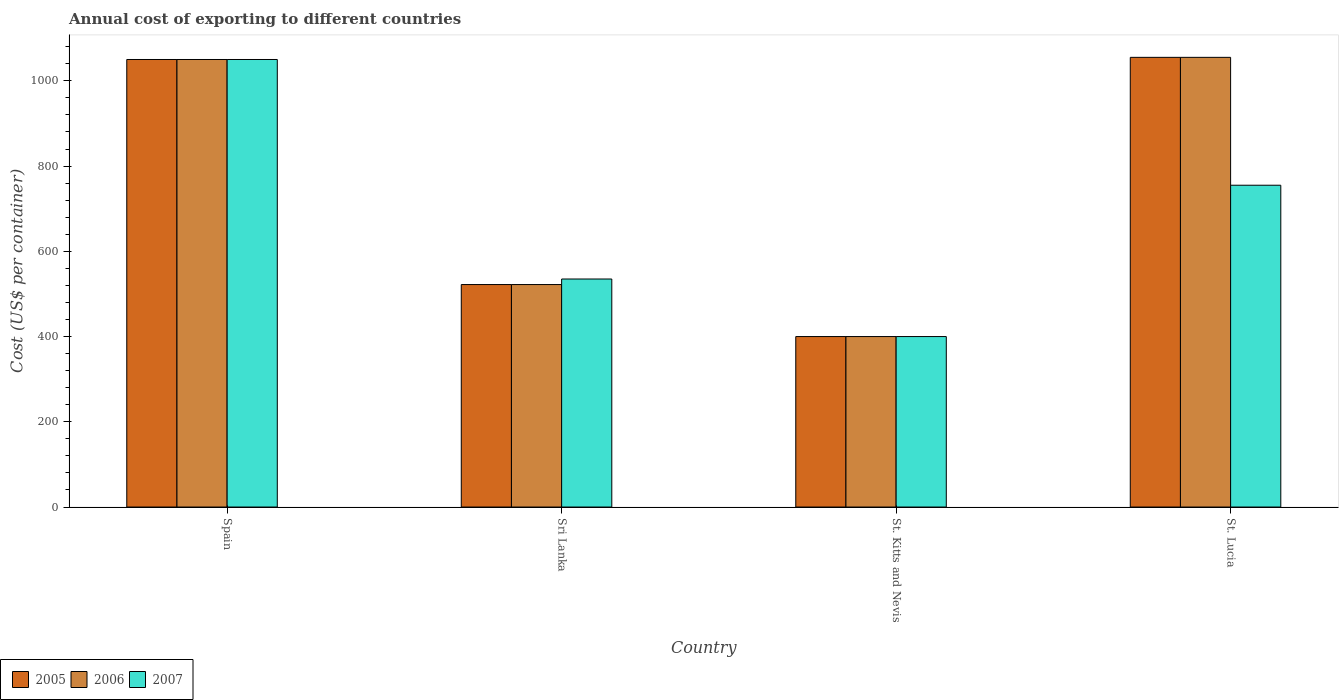How many groups of bars are there?
Your response must be concise. 4. How many bars are there on the 1st tick from the right?
Offer a very short reply. 3. What is the label of the 2nd group of bars from the left?
Your response must be concise. Sri Lanka. In how many cases, is the number of bars for a given country not equal to the number of legend labels?
Keep it short and to the point. 0. Across all countries, what is the maximum total annual cost of exporting in 2007?
Provide a short and direct response. 1050. Across all countries, what is the minimum total annual cost of exporting in 2005?
Provide a succinct answer. 400. In which country was the total annual cost of exporting in 2006 maximum?
Keep it short and to the point. St. Lucia. In which country was the total annual cost of exporting in 2005 minimum?
Your answer should be compact. St. Kitts and Nevis. What is the total total annual cost of exporting in 2007 in the graph?
Your response must be concise. 2740. What is the difference between the total annual cost of exporting in 2006 in Sri Lanka and that in St. Lucia?
Provide a succinct answer. -533. What is the difference between the total annual cost of exporting in 2005 in St. Lucia and the total annual cost of exporting in 2007 in Sri Lanka?
Your answer should be compact. 520. What is the average total annual cost of exporting in 2005 per country?
Make the answer very short. 756.75. In how many countries, is the total annual cost of exporting in 2006 greater than 600 US$?
Your answer should be very brief. 2. What is the ratio of the total annual cost of exporting in 2007 in Sri Lanka to that in St. Kitts and Nevis?
Offer a terse response. 1.34. Is the difference between the total annual cost of exporting in 2006 in Spain and St. Lucia greater than the difference between the total annual cost of exporting in 2005 in Spain and St. Lucia?
Provide a succinct answer. No. What is the difference between the highest and the second highest total annual cost of exporting in 2005?
Your answer should be very brief. 528. What is the difference between the highest and the lowest total annual cost of exporting in 2007?
Your response must be concise. 650. In how many countries, is the total annual cost of exporting in 2007 greater than the average total annual cost of exporting in 2007 taken over all countries?
Provide a short and direct response. 2. Is the sum of the total annual cost of exporting in 2007 in St. Kitts and Nevis and St. Lucia greater than the maximum total annual cost of exporting in 2005 across all countries?
Keep it short and to the point. Yes. What does the 1st bar from the left in St. Lucia represents?
Provide a short and direct response. 2005. Are all the bars in the graph horizontal?
Provide a succinct answer. No. Where does the legend appear in the graph?
Offer a terse response. Bottom left. How are the legend labels stacked?
Provide a succinct answer. Horizontal. What is the title of the graph?
Give a very brief answer. Annual cost of exporting to different countries. What is the label or title of the X-axis?
Ensure brevity in your answer.  Country. What is the label or title of the Y-axis?
Offer a terse response. Cost (US$ per container). What is the Cost (US$ per container) of 2005 in Spain?
Your answer should be very brief. 1050. What is the Cost (US$ per container) in 2006 in Spain?
Your answer should be very brief. 1050. What is the Cost (US$ per container) in 2007 in Spain?
Your answer should be very brief. 1050. What is the Cost (US$ per container) in 2005 in Sri Lanka?
Keep it short and to the point. 522. What is the Cost (US$ per container) in 2006 in Sri Lanka?
Offer a very short reply. 522. What is the Cost (US$ per container) in 2007 in Sri Lanka?
Ensure brevity in your answer.  535. What is the Cost (US$ per container) in 2006 in St. Kitts and Nevis?
Offer a terse response. 400. What is the Cost (US$ per container) of 2007 in St. Kitts and Nevis?
Make the answer very short. 400. What is the Cost (US$ per container) in 2005 in St. Lucia?
Your answer should be very brief. 1055. What is the Cost (US$ per container) in 2006 in St. Lucia?
Your response must be concise. 1055. What is the Cost (US$ per container) of 2007 in St. Lucia?
Your answer should be very brief. 755. Across all countries, what is the maximum Cost (US$ per container) of 2005?
Provide a short and direct response. 1055. Across all countries, what is the maximum Cost (US$ per container) of 2006?
Ensure brevity in your answer.  1055. Across all countries, what is the maximum Cost (US$ per container) of 2007?
Keep it short and to the point. 1050. Across all countries, what is the minimum Cost (US$ per container) in 2005?
Your response must be concise. 400. Across all countries, what is the minimum Cost (US$ per container) in 2007?
Offer a very short reply. 400. What is the total Cost (US$ per container) of 2005 in the graph?
Provide a short and direct response. 3027. What is the total Cost (US$ per container) of 2006 in the graph?
Make the answer very short. 3027. What is the total Cost (US$ per container) of 2007 in the graph?
Give a very brief answer. 2740. What is the difference between the Cost (US$ per container) in 2005 in Spain and that in Sri Lanka?
Provide a succinct answer. 528. What is the difference between the Cost (US$ per container) in 2006 in Spain and that in Sri Lanka?
Offer a very short reply. 528. What is the difference between the Cost (US$ per container) in 2007 in Spain and that in Sri Lanka?
Your answer should be very brief. 515. What is the difference between the Cost (US$ per container) in 2005 in Spain and that in St. Kitts and Nevis?
Provide a short and direct response. 650. What is the difference between the Cost (US$ per container) in 2006 in Spain and that in St. Kitts and Nevis?
Your answer should be very brief. 650. What is the difference between the Cost (US$ per container) in 2007 in Spain and that in St. Kitts and Nevis?
Your response must be concise. 650. What is the difference between the Cost (US$ per container) of 2005 in Spain and that in St. Lucia?
Your response must be concise. -5. What is the difference between the Cost (US$ per container) of 2006 in Spain and that in St. Lucia?
Make the answer very short. -5. What is the difference between the Cost (US$ per container) of 2007 in Spain and that in St. Lucia?
Ensure brevity in your answer.  295. What is the difference between the Cost (US$ per container) of 2005 in Sri Lanka and that in St. Kitts and Nevis?
Offer a very short reply. 122. What is the difference between the Cost (US$ per container) in 2006 in Sri Lanka and that in St. Kitts and Nevis?
Ensure brevity in your answer.  122. What is the difference between the Cost (US$ per container) of 2007 in Sri Lanka and that in St. Kitts and Nevis?
Offer a terse response. 135. What is the difference between the Cost (US$ per container) of 2005 in Sri Lanka and that in St. Lucia?
Your answer should be compact. -533. What is the difference between the Cost (US$ per container) in 2006 in Sri Lanka and that in St. Lucia?
Your answer should be very brief. -533. What is the difference between the Cost (US$ per container) in 2007 in Sri Lanka and that in St. Lucia?
Your answer should be very brief. -220. What is the difference between the Cost (US$ per container) of 2005 in St. Kitts and Nevis and that in St. Lucia?
Make the answer very short. -655. What is the difference between the Cost (US$ per container) in 2006 in St. Kitts and Nevis and that in St. Lucia?
Provide a short and direct response. -655. What is the difference between the Cost (US$ per container) of 2007 in St. Kitts and Nevis and that in St. Lucia?
Your answer should be compact. -355. What is the difference between the Cost (US$ per container) of 2005 in Spain and the Cost (US$ per container) of 2006 in Sri Lanka?
Make the answer very short. 528. What is the difference between the Cost (US$ per container) of 2005 in Spain and the Cost (US$ per container) of 2007 in Sri Lanka?
Ensure brevity in your answer.  515. What is the difference between the Cost (US$ per container) in 2006 in Spain and the Cost (US$ per container) in 2007 in Sri Lanka?
Provide a succinct answer. 515. What is the difference between the Cost (US$ per container) of 2005 in Spain and the Cost (US$ per container) of 2006 in St. Kitts and Nevis?
Keep it short and to the point. 650. What is the difference between the Cost (US$ per container) in 2005 in Spain and the Cost (US$ per container) in 2007 in St. Kitts and Nevis?
Your response must be concise. 650. What is the difference between the Cost (US$ per container) of 2006 in Spain and the Cost (US$ per container) of 2007 in St. Kitts and Nevis?
Your response must be concise. 650. What is the difference between the Cost (US$ per container) of 2005 in Spain and the Cost (US$ per container) of 2007 in St. Lucia?
Your answer should be very brief. 295. What is the difference between the Cost (US$ per container) in 2006 in Spain and the Cost (US$ per container) in 2007 in St. Lucia?
Offer a very short reply. 295. What is the difference between the Cost (US$ per container) in 2005 in Sri Lanka and the Cost (US$ per container) in 2006 in St. Kitts and Nevis?
Offer a terse response. 122. What is the difference between the Cost (US$ per container) in 2005 in Sri Lanka and the Cost (US$ per container) in 2007 in St. Kitts and Nevis?
Offer a terse response. 122. What is the difference between the Cost (US$ per container) of 2006 in Sri Lanka and the Cost (US$ per container) of 2007 in St. Kitts and Nevis?
Your answer should be compact. 122. What is the difference between the Cost (US$ per container) of 2005 in Sri Lanka and the Cost (US$ per container) of 2006 in St. Lucia?
Provide a short and direct response. -533. What is the difference between the Cost (US$ per container) of 2005 in Sri Lanka and the Cost (US$ per container) of 2007 in St. Lucia?
Ensure brevity in your answer.  -233. What is the difference between the Cost (US$ per container) of 2006 in Sri Lanka and the Cost (US$ per container) of 2007 in St. Lucia?
Offer a very short reply. -233. What is the difference between the Cost (US$ per container) of 2005 in St. Kitts and Nevis and the Cost (US$ per container) of 2006 in St. Lucia?
Provide a succinct answer. -655. What is the difference between the Cost (US$ per container) of 2005 in St. Kitts and Nevis and the Cost (US$ per container) of 2007 in St. Lucia?
Offer a terse response. -355. What is the difference between the Cost (US$ per container) of 2006 in St. Kitts and Nevis and the Cost (US$ per container) of 2007 in St. Lucia?
Your answer should be compact. -355. What is the average Cost (US$ per container) in 2005 per country?
Your response must be concise. 756.75. What is the average Cost (US$ per container) in 2006 per country?
Provide a short and direct response. 756.75. What is the average Cost (US$ per container) in 2007 per country?
Provide a succinct answer. 685. What is the difference between the Cost (US$ per container) in 2005 and Cost (US$ per container) in 2006 in Spain?
Offer a terse response. 0. What is the difference between the Cost (US$ per container) in 2005 and Cost (US$ per container) in 2007 in Spain?
Your answer should be very brief. 0. What is the difference between the Cost (US$ per container) in 2006 and Cost (US$ per container) in 2007 in Spain?
Give a very brief answer. 0. What is the difference between the Cost (US$ per container) in 2005 and Cost (US$ per container) in 2006 in Sri Lanka?
Ensure brevity in your answer.  0. What is the difference between the Cost (US$ per container) of 2005 and Cost (US$ per container) of 2007 in Sri Lanka?
Offer a very short reply. -13. What is the difference between the Cost (US$ per container) in 2005 and Cost (US$ per container) in 2006 in St. Kitts and Nevis?
Make the answer very short. 0. What is the difference between the Cost (US$ per container) in 2005 and Cost (US$ per container) in 2007 in St. Kitts and Nevis?
Provide a succinct answer. 0. What is the difference between the Cost (US$ per container) in 2006 and Cost (US$ per container) in 2007 in St. Kitts and Nevis?
Offer a very short reply. 0. What is the difference between the Cost (US$ per container) of 2005 and Cost (US$ per container) of 2006 in St. Lucia?
Make the answer very short. 0. What is the difference between the Cost (US$ per container) in 2005 and Cost (US$ per container) in 2007 in St. Lucia?
Offer a very short reply. 300. What is the difference between the Cost (US$ per container) of 2006 and Cost (US$ per container) of 2007 in St. Lucia?
Make the answer very short. 300. What is the ratio of the Cost (US$ per container) in 2005 in Spain to that in Sri Lanka?
Make the answer very short. 2.01. What is the ratio of the Cost (US$ per container) of 2006 in Spain to that in Sri Lanka?
Offer a very short reply. 2.01. What is the ratio of the Cost (US$ per container) of 2007 in Spain to that in Sri Lanka?
Keep it short and to the point. 1.96. What is the ratio of the Cost (US$ per container) of 2005 in Spain to that in St. Kitts and Nevis?
Offer a very short reply. 2.62. What is the ratio of the Cost (US$ per container) in 2006 in Spain to that in St. Kitts and Nevis?
Give a very brief answer. 2.62. What is the ratio of the Cost (US$ per container) in 2007 in Spain to that in St. Kitts and Nevis?
Give a very brief answer. 2.62. What is the ratio of the Cost (US$ per container) of 2005 in Spain to that in St. Lucia?
Keep it short and to the point. 1. What is the ratio of the Cost (US$ per container) in 2006 in Spain to that in St. Lucia?
Your answer should be very brief. 1. What is the ratio of the Cost (US$ per container) in 2007 in Spain to that in St. Lucia?
Keep it short and to the point. 1.39. What is the ratio of the Cost (US$ per container) in 2005 in Sri Lanka to that in St. Kitts and Nevis?
Offer a very short reply. 1.3. What is the ratio of the Cost (US$ per container) in 2006 in Sri Lanka to that in St. Kitts and Nevis?
Your answer should be very brief. 1.3. What is the ratio of the Cost (US$ per container) of 2007 in Sri Lanka to that in St. Kitts and Nevis?
Provide a succinct answer. 1.34. What is the ratio of the Cost (US$ per container) in 2005 in Sri Lanka to that in St. Lucia?
Ensure brevity in your answer.  0.49. What is the ratio of the Cost (US$ per container) of 2006 in Sri Lanka to that in St. Lucia?
Your response must be concise. 0.49. What is the ratio of the Cost (US$ per container) in 2007 in Sri Lanka to that in St. Lucia?
Make the answer very short. 0.71. What is the ratio of the Cost (US$ per container) of 2005 in St. Kitts and Nevis to that in St. Lucia?
Ensure brevity in your answer.  0.38. What is the ratio of the Cost (US$ per container) of 2006 in St. Kitts and Nevis to that in St. Lucia?
Provide a succinct answer. 0.38. What is the ratio of the Cost (US$ per container) of 2007 in St. Kitts and Nevis to that in St. Lucia?
Your response must be concise. 0.53. What is the difference between the highest and the second highest Cost (US$ per container) of 2005?
Provide a short and direct response. 5. What is the difference between the highest and the second highest Cost (US$ per container) in 2006?
Your answer should be very brief. 5. What is the difference between the highest and the second highest Cost (US$ per container) in 2007?
Make the answer very short. 295. What is the difference between the highest and the lowest Cost (US$ per container) in 2005?
Your response must be concise. 655. What is the difference between the highest and the lowest Cost (US$ per container) in 2006?
Your response must be concise. 655. What is the difference between the highest and the lowest Cost (US$ per container) in 2007?
Provide a succinct answer. 650. 